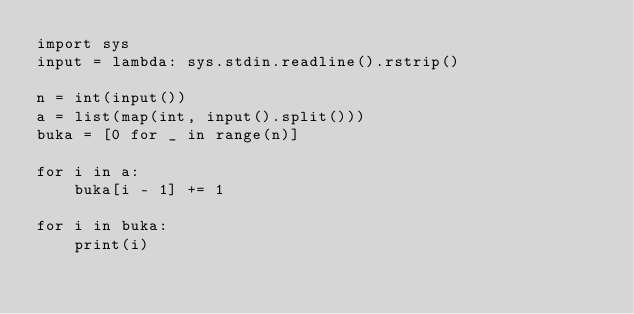Convert code to text. <code><loc_0><loc_0><loc_500><loc_500><_Python_>import sys
input = lambda: sys.stdin.readline().rstrip()

n = int(input())
a = list(map(int, input().split()))
buka = [0 for _ in range(n)]

for i in a:
    buka[i - 1] += 1

for i in buka:
    print(i)
</code> 